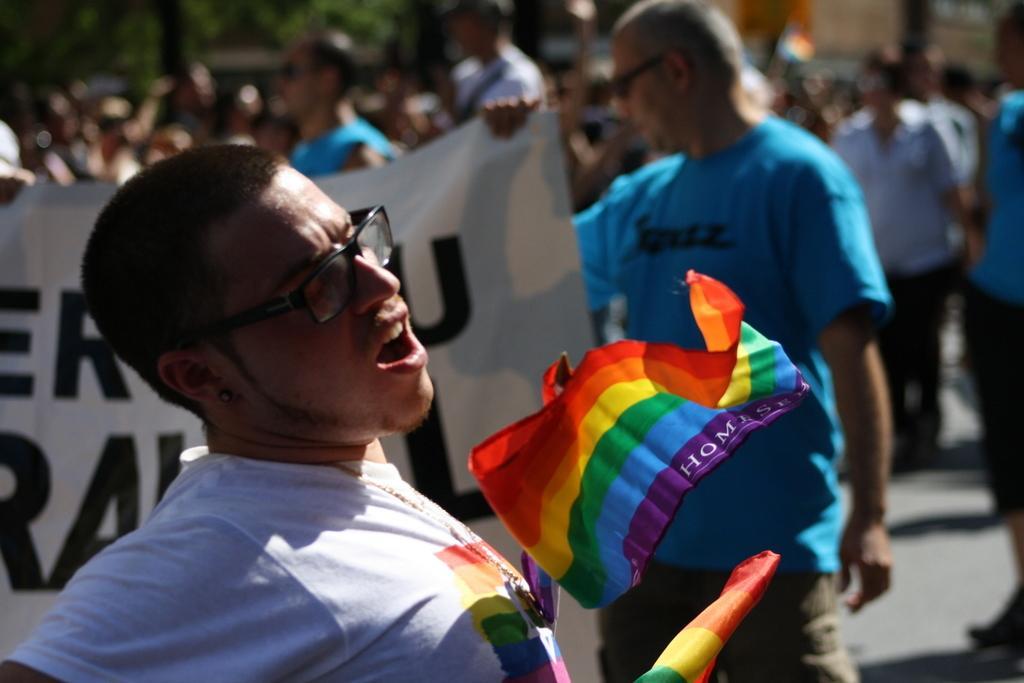How would you summarize this image in a sentence or two? In this image, we can see a person is wearing glasses and opens his mouth. Here we can see flags. Background there is a blur view. Here we can see a group of people on the road. Here a person is holding a banner. 